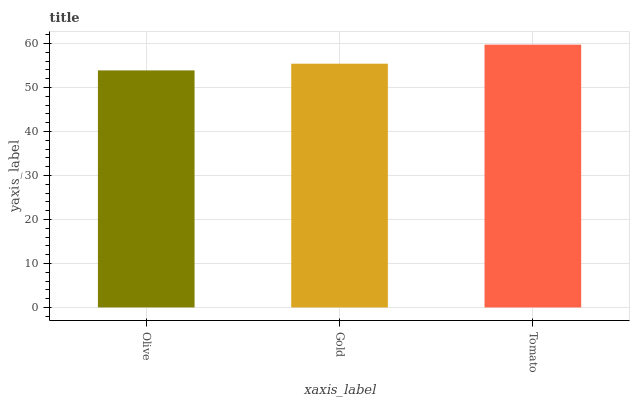Is Gold the minimum?
Answer yes or no. No. Is Gold the maximum?
Answer yes or no. No. Is Gold greater than Olive?
Answer yes or no. Yes. Is Olive less than Gold?
Answer yes or no. Yes. Is Olive greater than Gold?
Answer yes or no. No. Is Gold less than Olive?
Answer yes or no. No. Is Gold the high median?
Answer yes or no. Yes. Is Gold the low median?
Answer yes or no. Yes. Is Tomato the high median?
Answer yes or no. No. Is Tomato the low median?
Answer yes or no. No. 